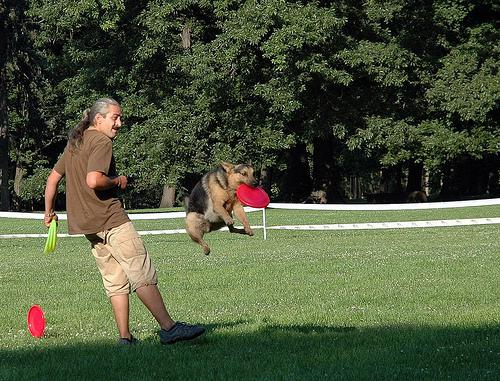Question: where is the dog?
Choices:
A. On the bench.
B. By the building.
C. Near the fence.
D. Next to the man.
Answer with the letter. Answer: D Question: how did the dog get the frisbee?
Choices:
A. It was thrown to him.
B. He picked it up.
C. He found it.
D. By jumping for it.
Answer with the letter. Answer: D Question: when was the photo taken?
Choices:
A. Night.
B. Noon.
C. Evening.
D. During the day.
Answer with the letter. Answer: D Question: why is the man there?
Choices:
A. To jog.
B. To swim.
C. To throw frisbees to the dog.
D. To rest.
Answer with the letter. Answer: C 